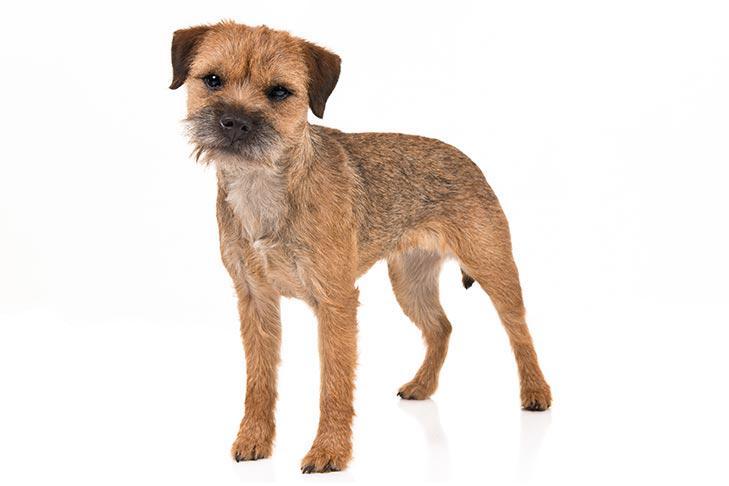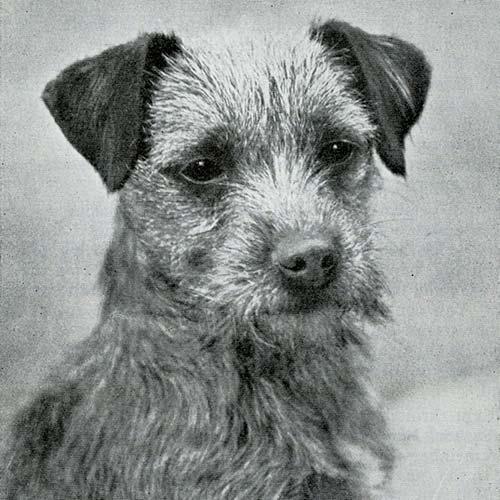The first image is the image on the left, the second image is the image on the right. Evaluate the accuracy of this statement regarding the images: "The left image shows a dog sitting with all paws on the grass.". Is it true? Answer yes or no. No. The first image is the image on the left, the second image is the image on the right. Analyze the images presented: Is the assertion "The left and right image contains the same number of dogs with one running on grass." valid? Answer yes or no. No. 